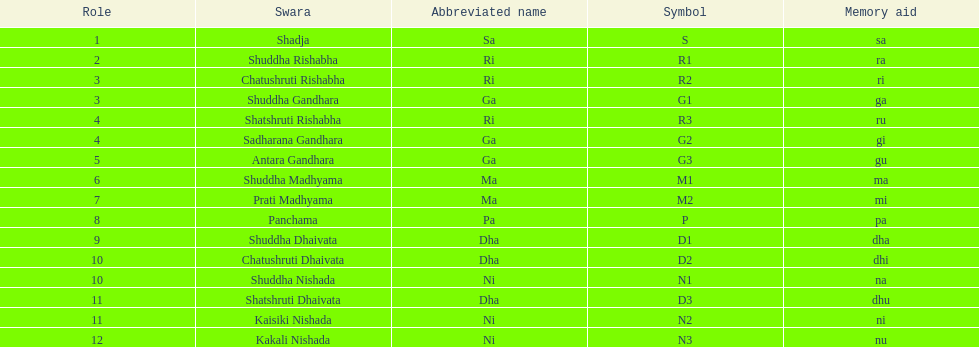What is the overall count of positions mentioned? 16. 